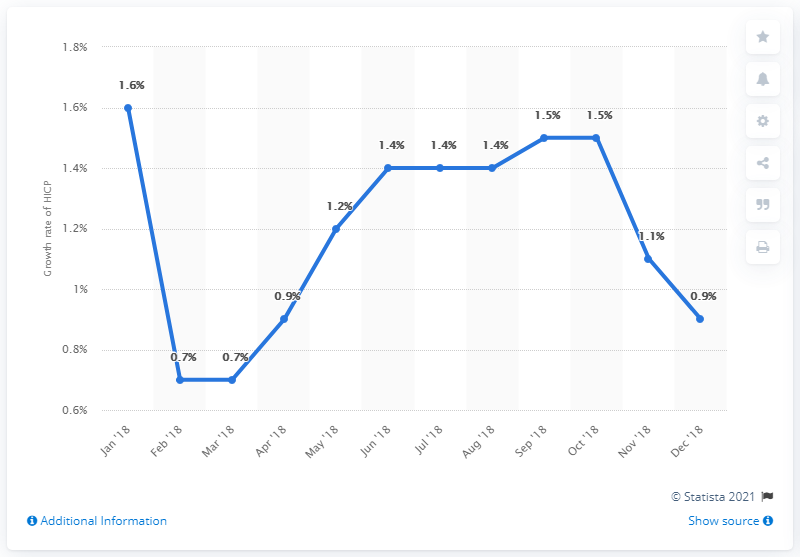Point out several critical features in this image. The number of years with the lowest value is two. The inflation rate in December 2018 was 0.9%. The difference between the lowest and highest value is 0.9. 